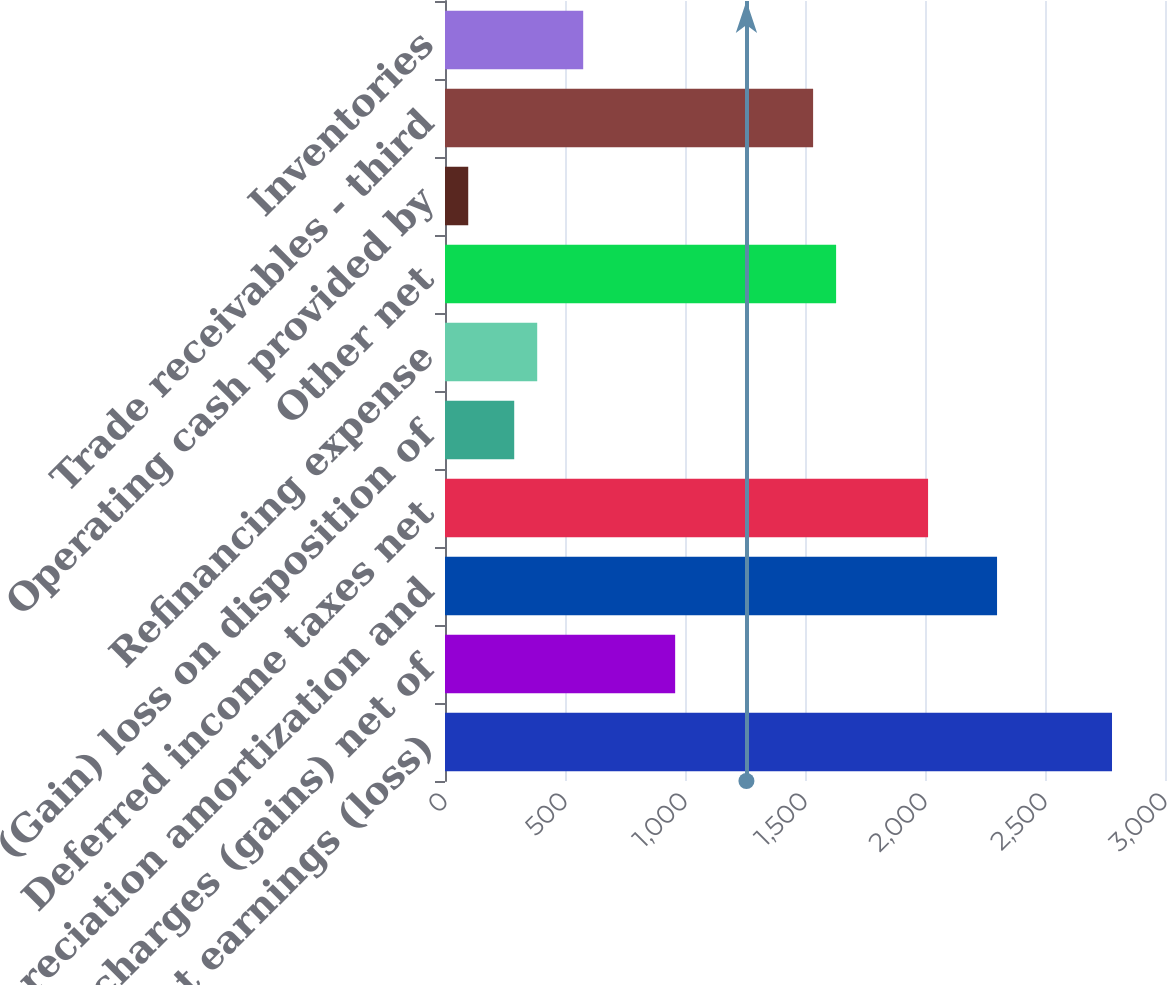<chart> <loc_0><loc_0><loc_500><loc_500><bar_chart><fcel>Net earnings (loss)<fcel>Other charges (gains) net of<fcel>Depreciation amortization and<fcel>Deferred income taxes net<fcel>(Gain) loss on disposition of<fcel>Refinancing expense<fcel>Other net<fcel>Operating cash provided by<fcel>Trade receivables - third<fcel>Inventories<nl><fcel>2779.2<fcel>959<fcel>2300.2<fcel>2012.8<fcel>288.4<fcel>384.2<fcel>1629.6<fcel>96.8<fcel>1533.8<fcel>575.8<nl></chart> 